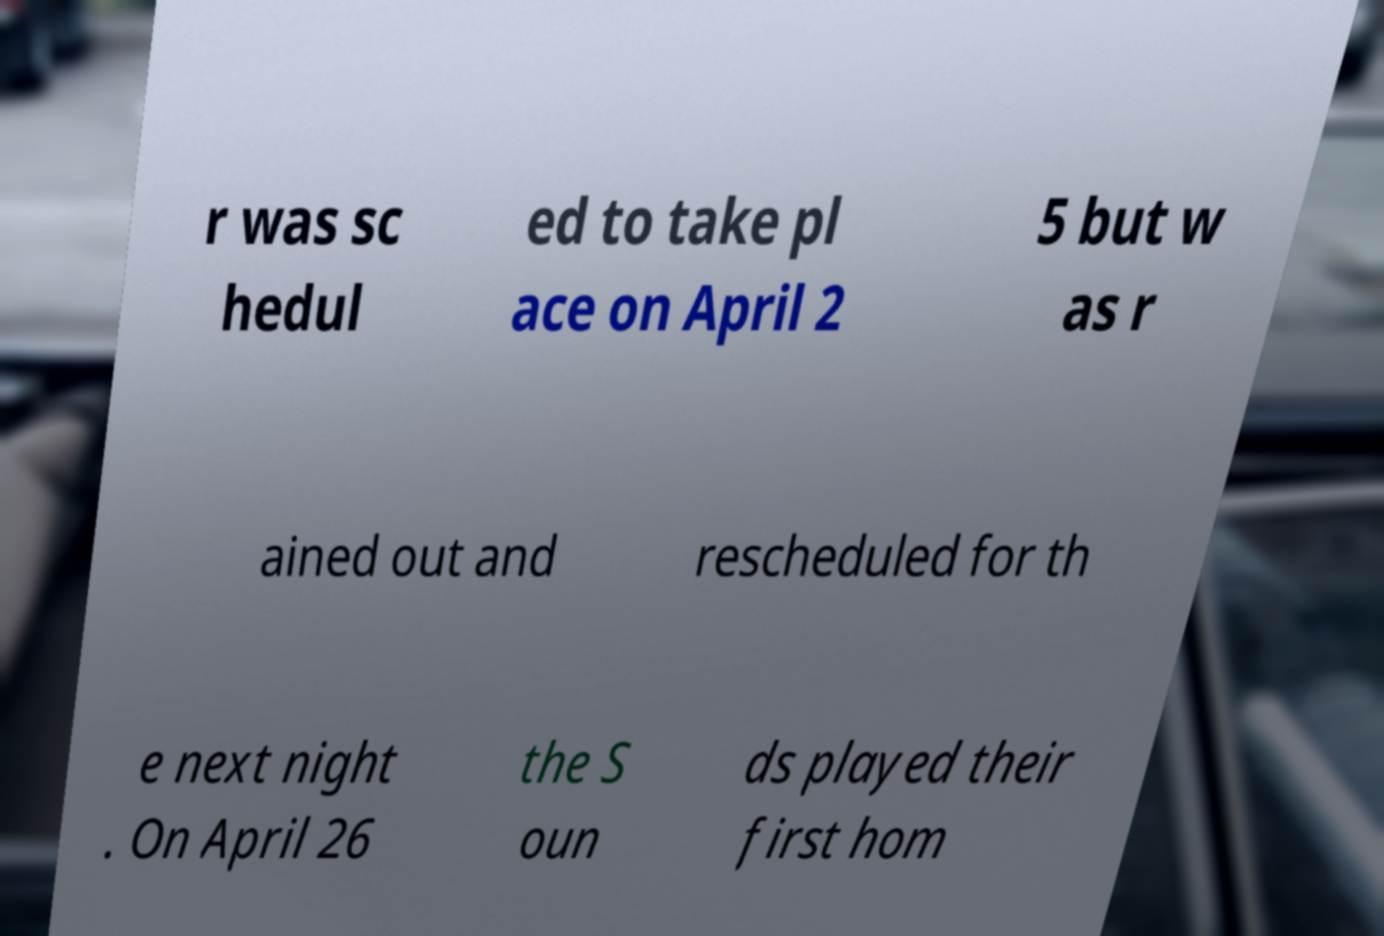Please identify and transcribe the text found in this image. r was sc hedul ed to take pl ace on April 2 5 but w as r ained out and rescheduled for th e next night . On April 26 the S oun ds played their first hom 